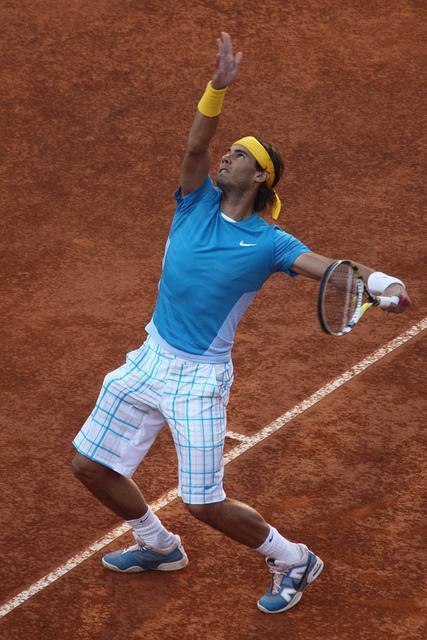How many elephants are there?
Give a very brief answer. 0. 